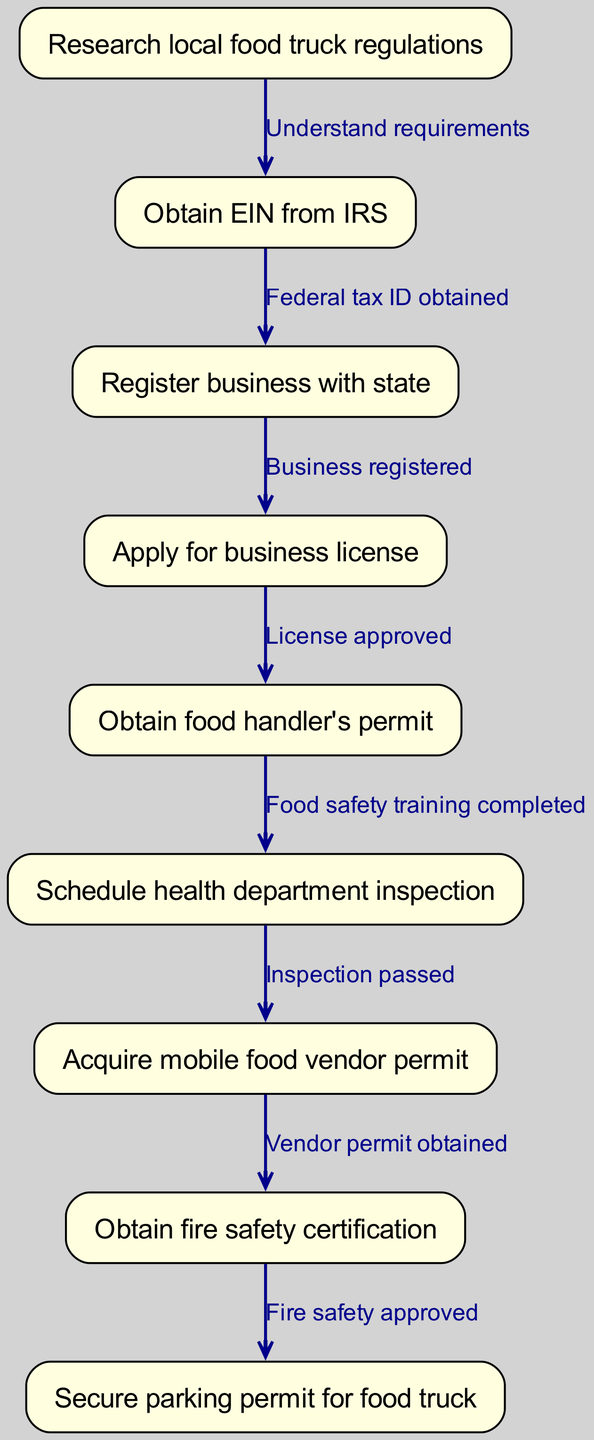What is the first step in the pathway? The diagram shows that the first step (node "1") is "Research local food truck regulations."
Answer: Research local food truck regulations How many total nodes are present in the diagram? The diagram lists a total of 9 nodes, as enumerated from 1 to 9 in the pathway.
Answer: 9 What is the relationship between "Obtain EIN from IRS" and "Register business with state"? The edge connects node "2" ("Obtain EIN from IRS") to node "3" ("Register business with state") with the label "Federal tax ID obtained," indicating this is a prerequisite action.
Answer: Federal tax ID obtained What is required before applying for a business license? The pathway indicates that "Business registered," which corresponds to node "3," must be completed before applying for a business license (node "4").
Answer: Business registered Which step follows after obtaining the food handler's permit? According to the flow, the step that follows "Obtain food handler's permit" (node "5") is scheduling a health department inspection (node "6").
Answer: Schedule health department inspection How many edges connect to the "Acquire mobile food vendor permit"? The “Acquire mobile food vendor permit” is connected by one edge, coming from node "6" ("Inspection passed") to node "7."
Answer: 1 What must be approved after obtaining the mobile food vendor permit? The diagram indicates that "Obtain fire safety certification" (node "8") must follow the acquisition of the mobile food vendor permit (node "7").
Answer: Obtain fire safety certification Which step indicates that food safety training has been completed? The food handler's permit (node "5") reflects the completion of food safety training as per the connection to the scheduling of the health department inspection (node "6").
Answer: Obtain food handler's permit What is the last step in the pathway? The final step listed is "Secure parking permit for food truck" (node "9"), which is the last action required according to the flow of the diagram.
Answer: Secure parking permit for food truck 